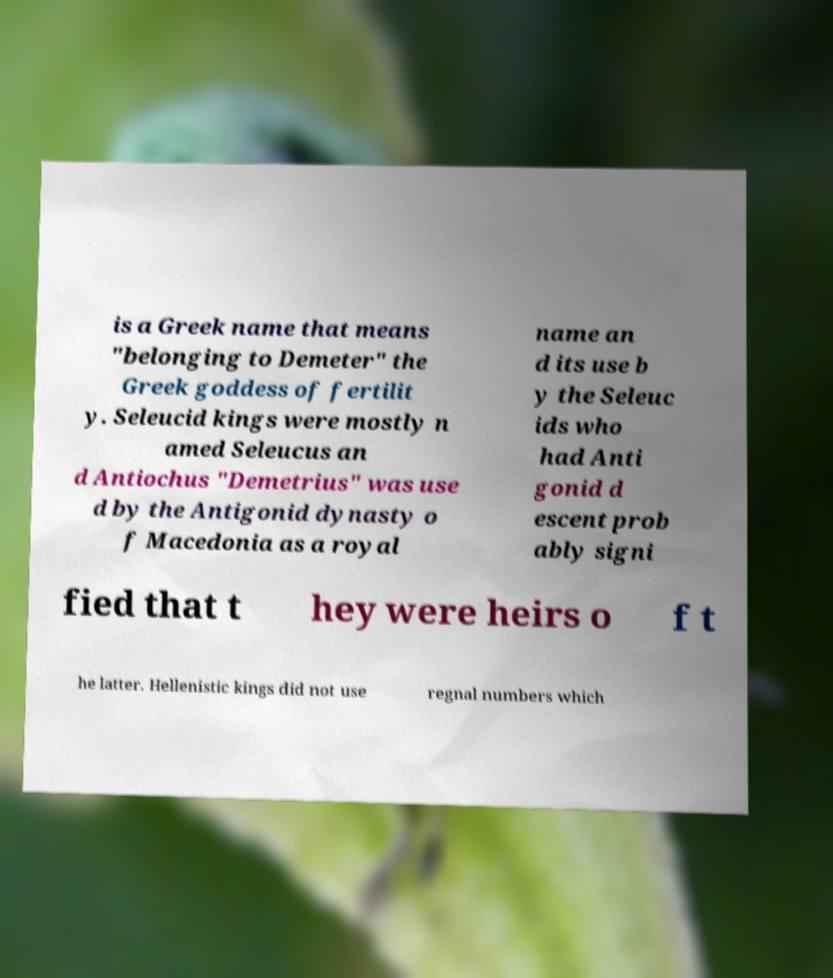Please identify and transcribe the text found in this image. is a Greek name that means "belonging to Demeter" the Greek goddess of fertilit y. Seleucid kings were mostly n amed Seleucus an d Antiochus "Demetrius" was use d by the Antigonid dynasty o f Macedonia as a royal name an d its use b y the Seleuc ids who had Anti gonid d escent prob ably signi fied that t hey were heirs o f t he latter. Hellenistic kings did not use regnal numbers which 